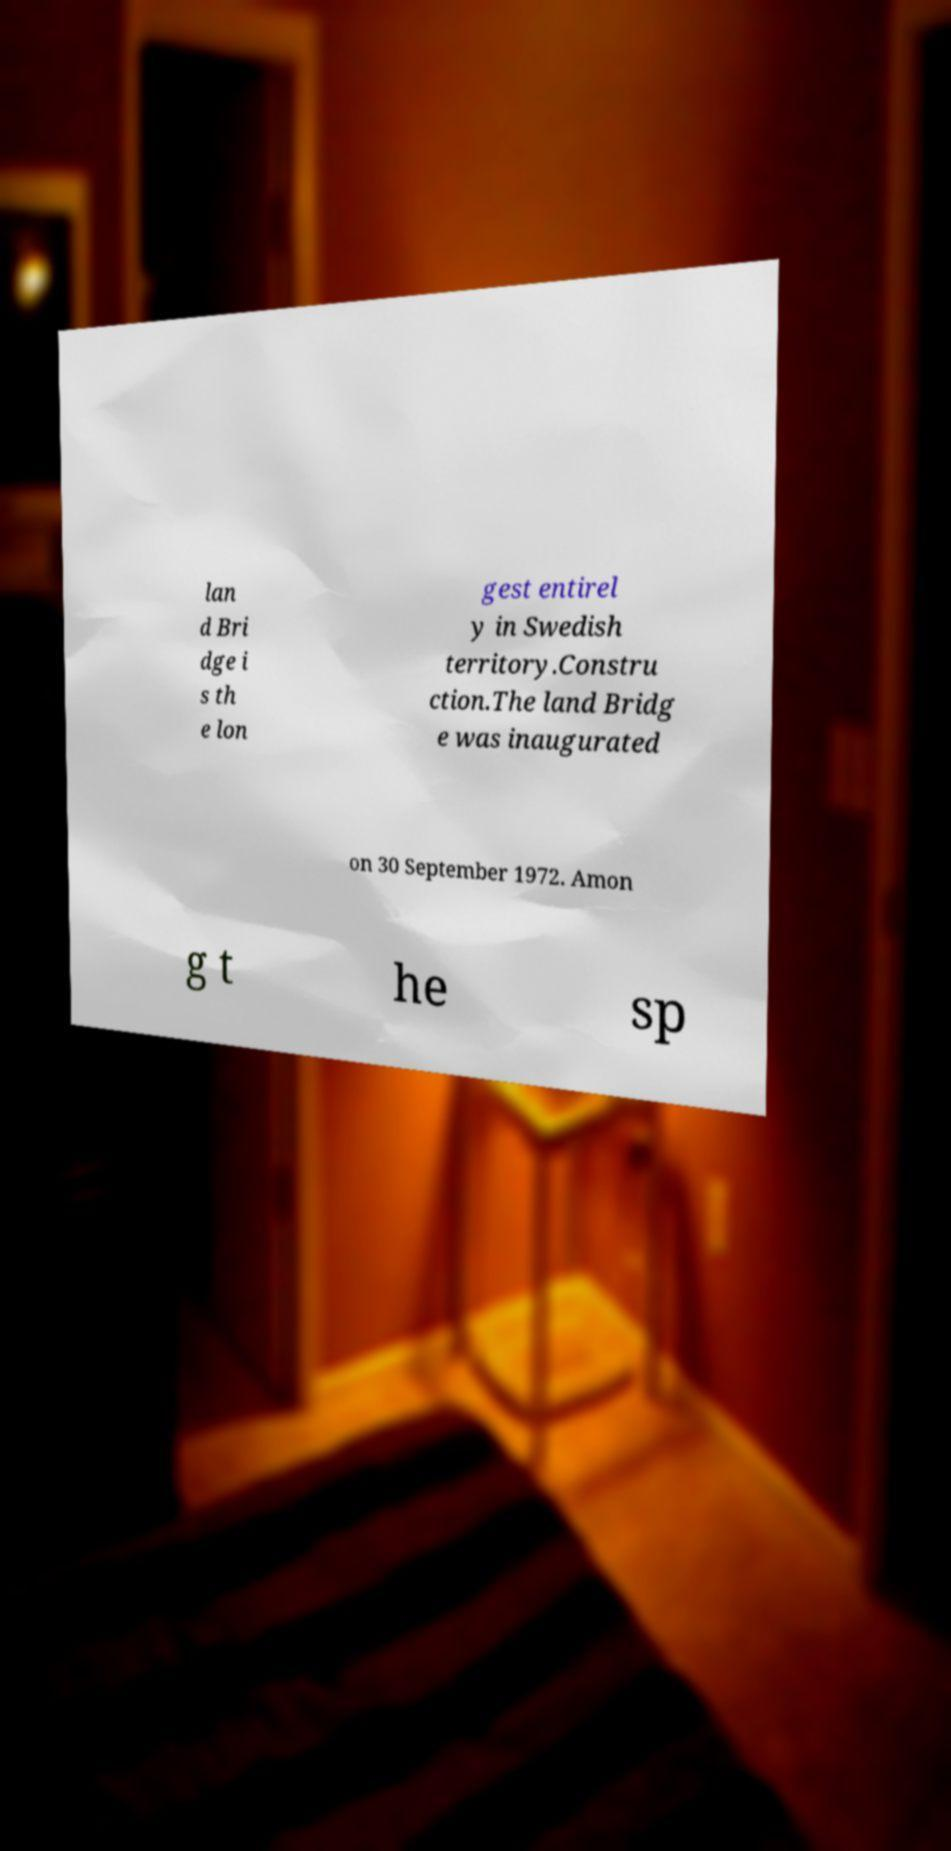There's text embedded in this image that I need extracted. Can you transcribe it verbatim? lan d Bri dge i s th e lon gest entirel y in Swedish territory.Constru ction.The land Bridg e was inaugurated on 30 September 1972. Amon g t he sp 